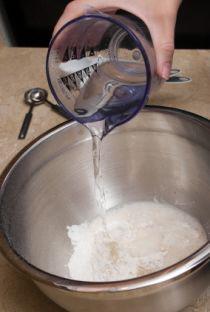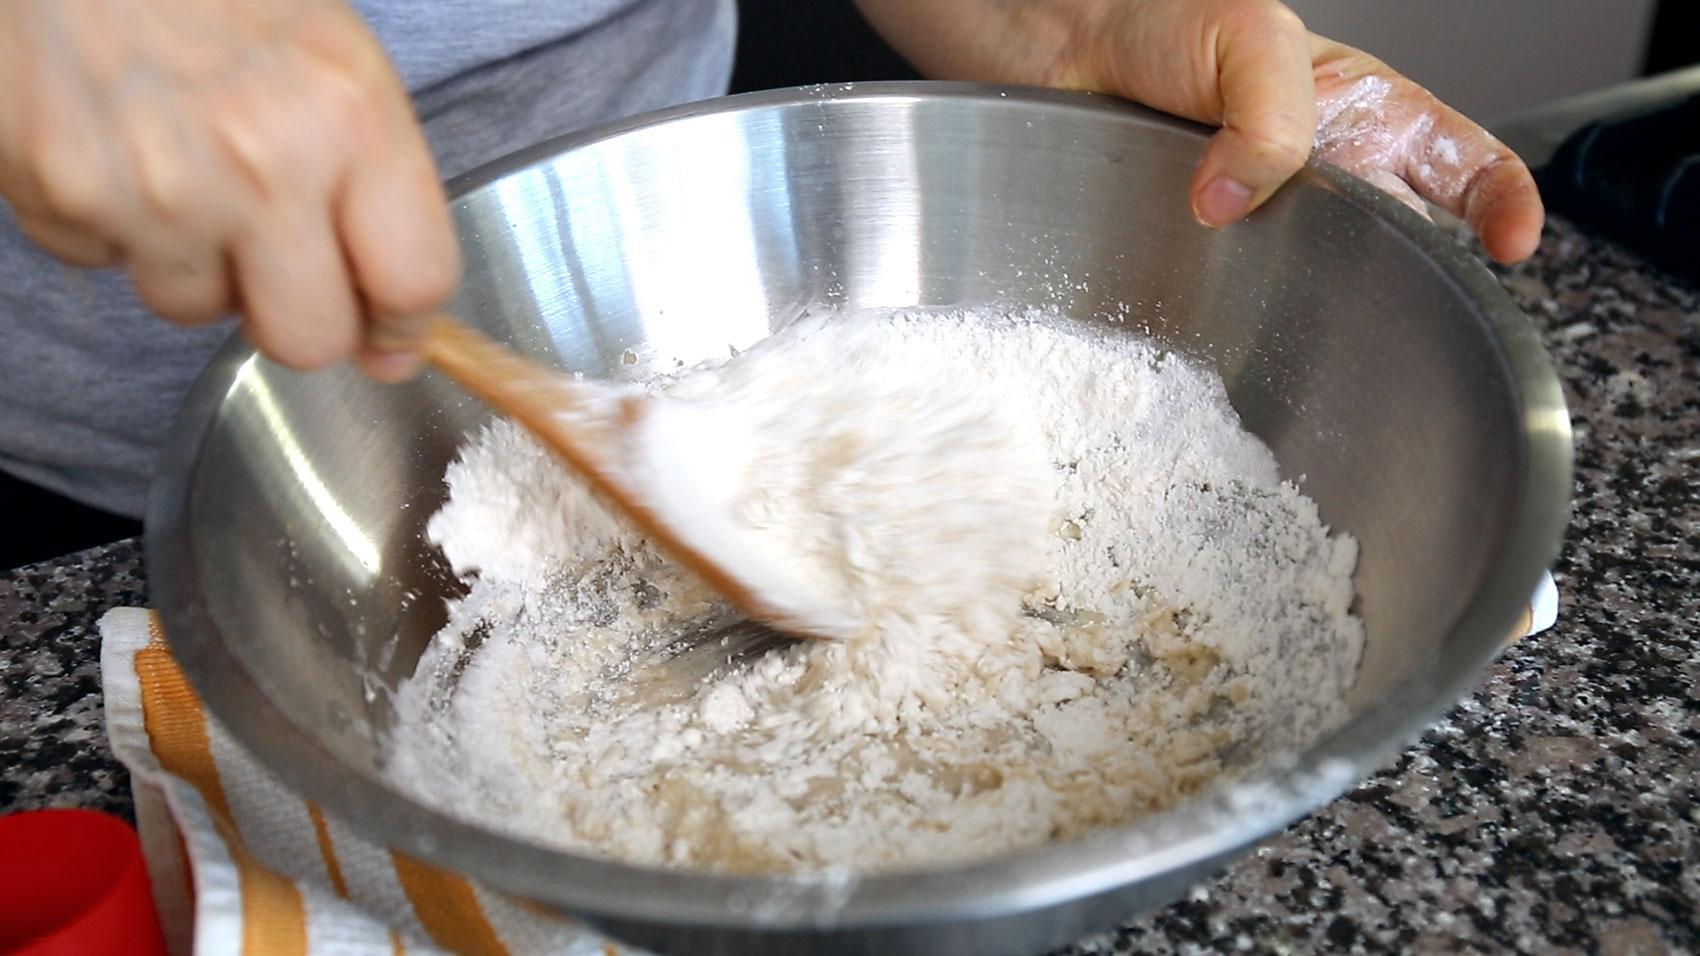The first image is the image on the left, the second image is the image on the right. Given the left and right images, does the statement "In one of the images, the person's hand is pouring an ingredient into the bowl." hold true? Answer yes or no. Yes. The first image is the image on the left, the second image is the image on the right. Evaluate the accuracy of this statement regarding the images: "The right image shows one hand holding a spoon in a silver-colored bowl as the other hand grips the edge of the bowl.". Is it true? Answer yes or no. Yes. 